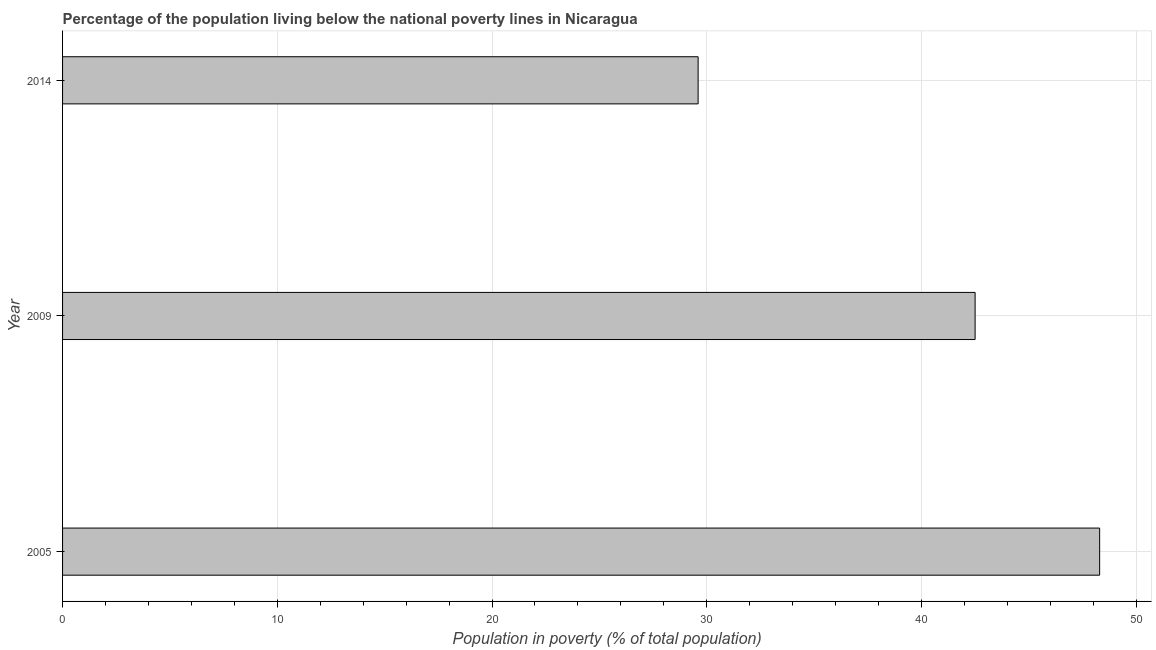What is the title of the graph?
Provide a succinct answer. Percentage of the population living below the national poverty lines in Nicaragua. What is the label or title of the X-axis?
Provide a succinct answer. Population in poverty (% of total population). What is the percentage of population living below poverty line in 2014?
Provide a short and direct response. 29.6. Across all years, what is the maximum percentage of population living below poverty line?
Provide a succinct answer. 48.3. Across all years, what is the minimum percentage of population living below poverty line?
Provide a short and direct response. 29.6. What is the sum of the percentage of population living below poverty line?
Ensure brevity in your answer.  120.4. What is the difference between the percentage of population living below poverty line in 2009 and 2014?
Your response must be concise. 12.9. What is the average percentage of population living below poverty line per year?
Provide a succinct answer. 40.13. What is the median percentage of population living below poverty line?
Provide a short and direct response. 42.5. In how many years, is the percentage of population living below poverty line greater than 28 %?
Keep it short and to the point. 3. What is the ratio of the percentage of population living below poverty line in 2005 to that in 2014?
Ensure brevity in your answer.  1.63. Is the percentage of population living below poverty line in 2005 less than that in 2014?
Your response must be concise. No. In how many years, is the percentage of population living below poverty line greater than the average percentage of population living below poverty line taken over all years?
Ensure brevity in your answer.  2. How many bars are there?
Offer a terse response. 3. What is the Population in poverty (% of total population) of 2005?
Your response must be concise. 48.3. What is the Population in poverty (% of total population) in 2009?
Provide a succinct answer. 42.5. What is the Population in poverty (% of total population) in 2014?
Offer a terse response. 29.6. What is the difference between the Population in poverty (% of total population) in 2005 and 2009?
Offer a terse response. 5.8. What is the difference between the Population in poverty (% of total population) in 2009 and 2014?
Offer a very short reply. 12.9. What is the ratio of the Population in poverty (% of total population) in 2005 to that in 2009?
Ensure brevity in your answer.  1.14. What is the ratio of the Population in poverty (% of total population) in 2005 to that in 2014?
Ensure brevity in your answer.  1.63. What is the ratio of the Population in poverty (% of total population) in 2009 to that in 2014?
Offer a terse response. 1.44. 